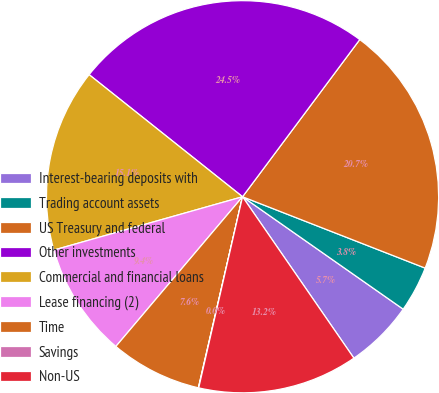<chart> <loc_0><loc_0><loc_500><loc_500><pie_chart><fcel>Interest-bearing deposits with<fcel>Trading account assets<fcel>US Treasury and federal<fcel>Other investments<fcel>Commercial and financial loans<fcel>Lease financing (2)<fcel>Time<fcel>Savings<fcel>Non-US<nl><fcel>5.67%<fcel>3.79%<fcel>20.73%<fcel>24.5%<fcel>15.08%<fcel>9.44%<fcel>7.56%<fcel>0.03%<fcel>13.2%<nl></chart> 